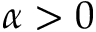<formula> <loc_0><loc_0><loc_500><loc_500>\alpha > 0</formula> 